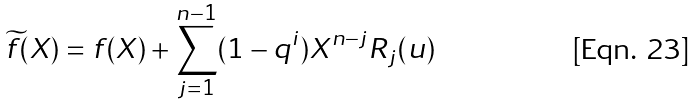Convert formula to latex. <formula><loc_0><loc_0><loc_500><loc_500>\widetilde { f } ( X ) = f ( X ) + \sum _ { j = 1 } ^ { n - 1 } ( 1 - q ^ { i } ) X ^ { n - j } R _ { j } ( u )</formula> 